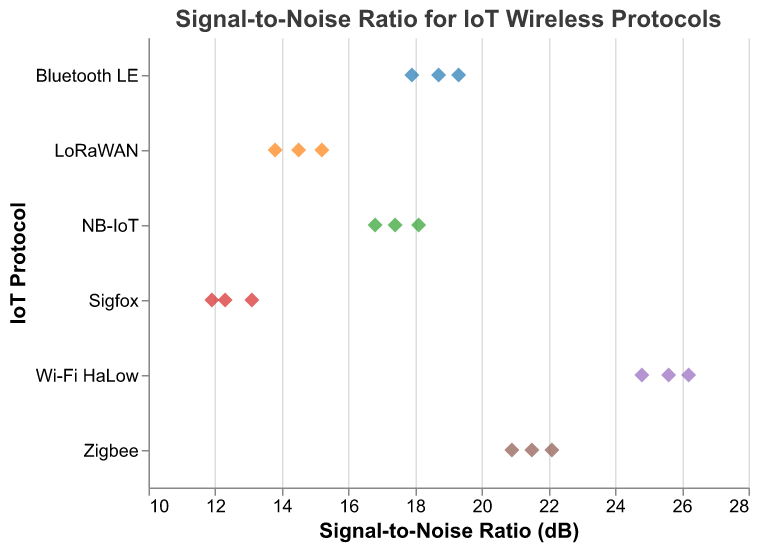What is the title of the plot? The title of the plot is located at the top of the figure and provides a concise summary of what the plot represents.
Answer: Signal-to-Noise Ratio for IoT Wireless Protocols How many IoT protocols are displayed in the plot? The different IoT protocols are displayed along the y-axis. Counting the unique labels will give the number of protocols shown.
Answer: 6 Which IoT protocol has the highest Signal-to-Noise Ratio (SNR)? The highest SNR can be found by identifying the highest point along the x-axis, then noting the corresponding protocol on the y-axis.
Answer: Wi-Fi HaLow What is the range of Signal-to-Noise Ratios for Zigbee? Identify the minimum and maximum SNR values for the Zigbee protocol by looking at the points on the x-axis corresponding to Zigbee on the y-axis.
Answer: 20.9 to 22.1 dB Which IoT protocol has the most consistent Signal-to-Noise Ratios? Consistency can be inferred from how closely clustered the points are for each protocol. The smaller the spread, the more consistent the SNR values.
Answer: Sigfox Compare the average Signal-to-Noise Ratios of Bluetooth LE and NB-IoT. Calculate the averages for both Bluetooth LE and NB-IoT by summing their SNR values and dividing by the number of points, then compare the two averages.
Answer: Bluetooth LE: 18.6 dB, NB-IoT: 17.43 dB Which protocol exhibits the greatest variation in its SNR values? Variation can be observed by noting the spread of the points for each protocol. The protocol with the widest spread demonstrates the greatest variation.
Answer: Wi-Fi HaLow Order the protocols by their maximum Signal-to-Noise Ratio. Identify the maximum SNR value for each protocol and then arrange the protocols in descending order based on these values.
Answer: Wi-Fi HaLow > Zigbee > Bluetooth LE > NB-IoT > LoRaWAN > Sigfox What is the average Signal-to-Noise Ratio across all protocols? Sum all the SNR values from the plot and divide by the total number of data points to find the average.
Answer: 18.1 dB Is there any protocol with all SNR values below 15 dB? Observe each protocol's set of points to check if all their SNRs fall below the 15 dB mark.
Answer: Sigfox 